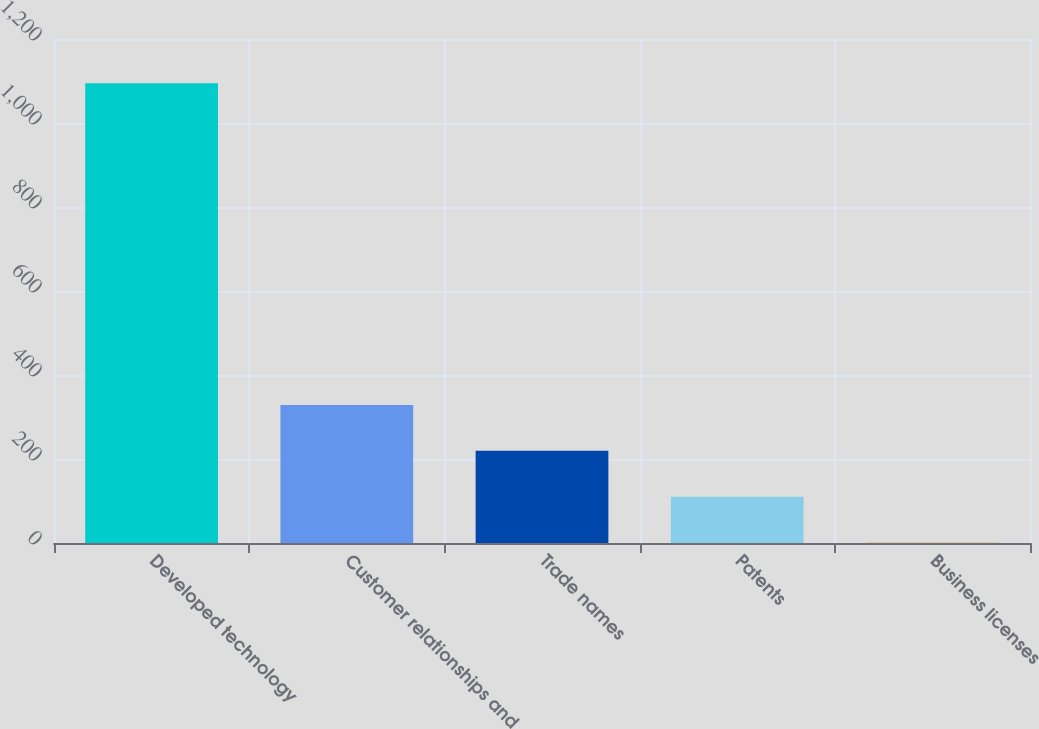<chart> <loc_0><loc_0><loc_500><loc_500><bar_chart><fcel>Developed technology<fcel>Customer relationships and<fcel>Trade names<fcel>Patents<fcel>Business licenses<nl><fcel>1094.5<fcel>328.77<fcel>219.38<fcel>109.99<fcel>0.6<nl></chart> 